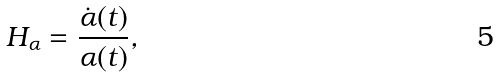Convert formula to latex. <formula><loc_0><loc_0><loc_500><loc_500>H _ { \alpha } = \frac { \dot { \alpha } ( t ) } { \alpha ( t ) } ,</formula> 